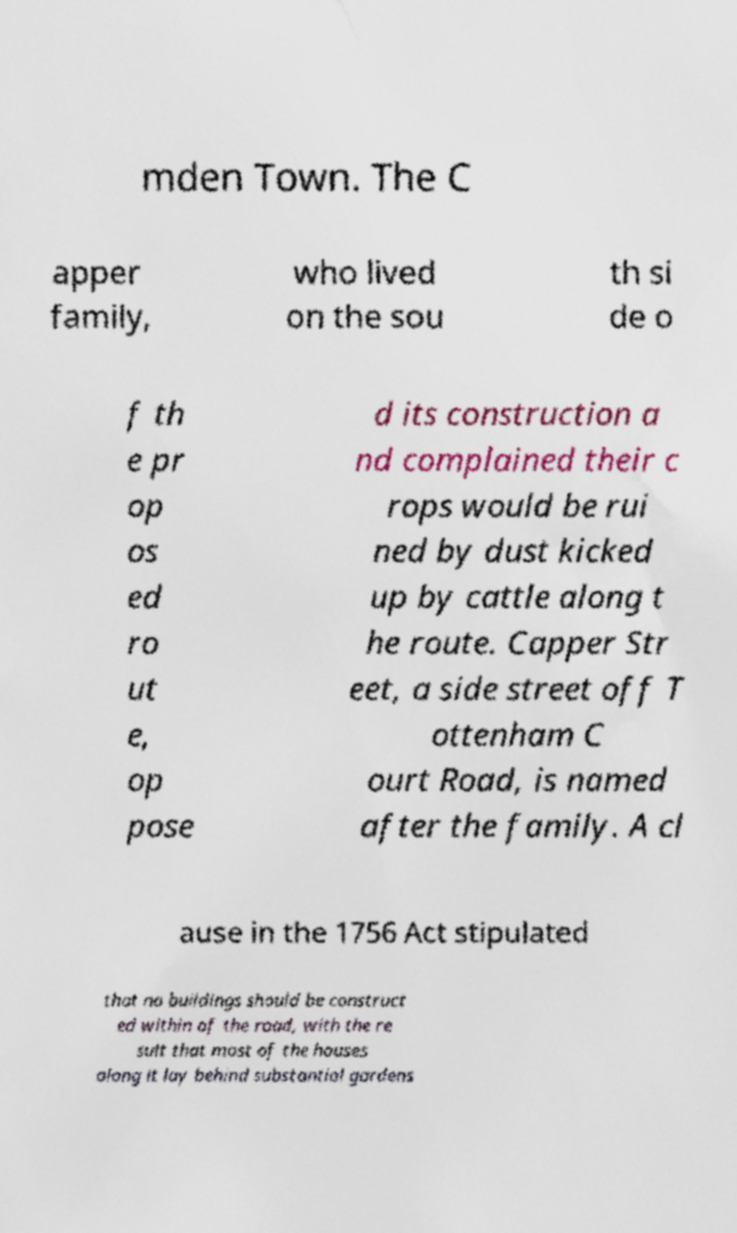Can you accurately transcribe the text from the provided image for me? mden Town. The C apper family, who lived on the sou th si de o f th e pr op os ed ro ut e, op pose d its construction a nd complained their c rops would be rui ned by dust kicked up by cattle along t he route. Capper Str eet, a side street off T ottenham C ourt Road, is named after the family. A cl ause in the 1756 Act stipulated that no buildings should be construct ed within of the road, with the re sult that most of the houses along it lay behind substantial gardens 